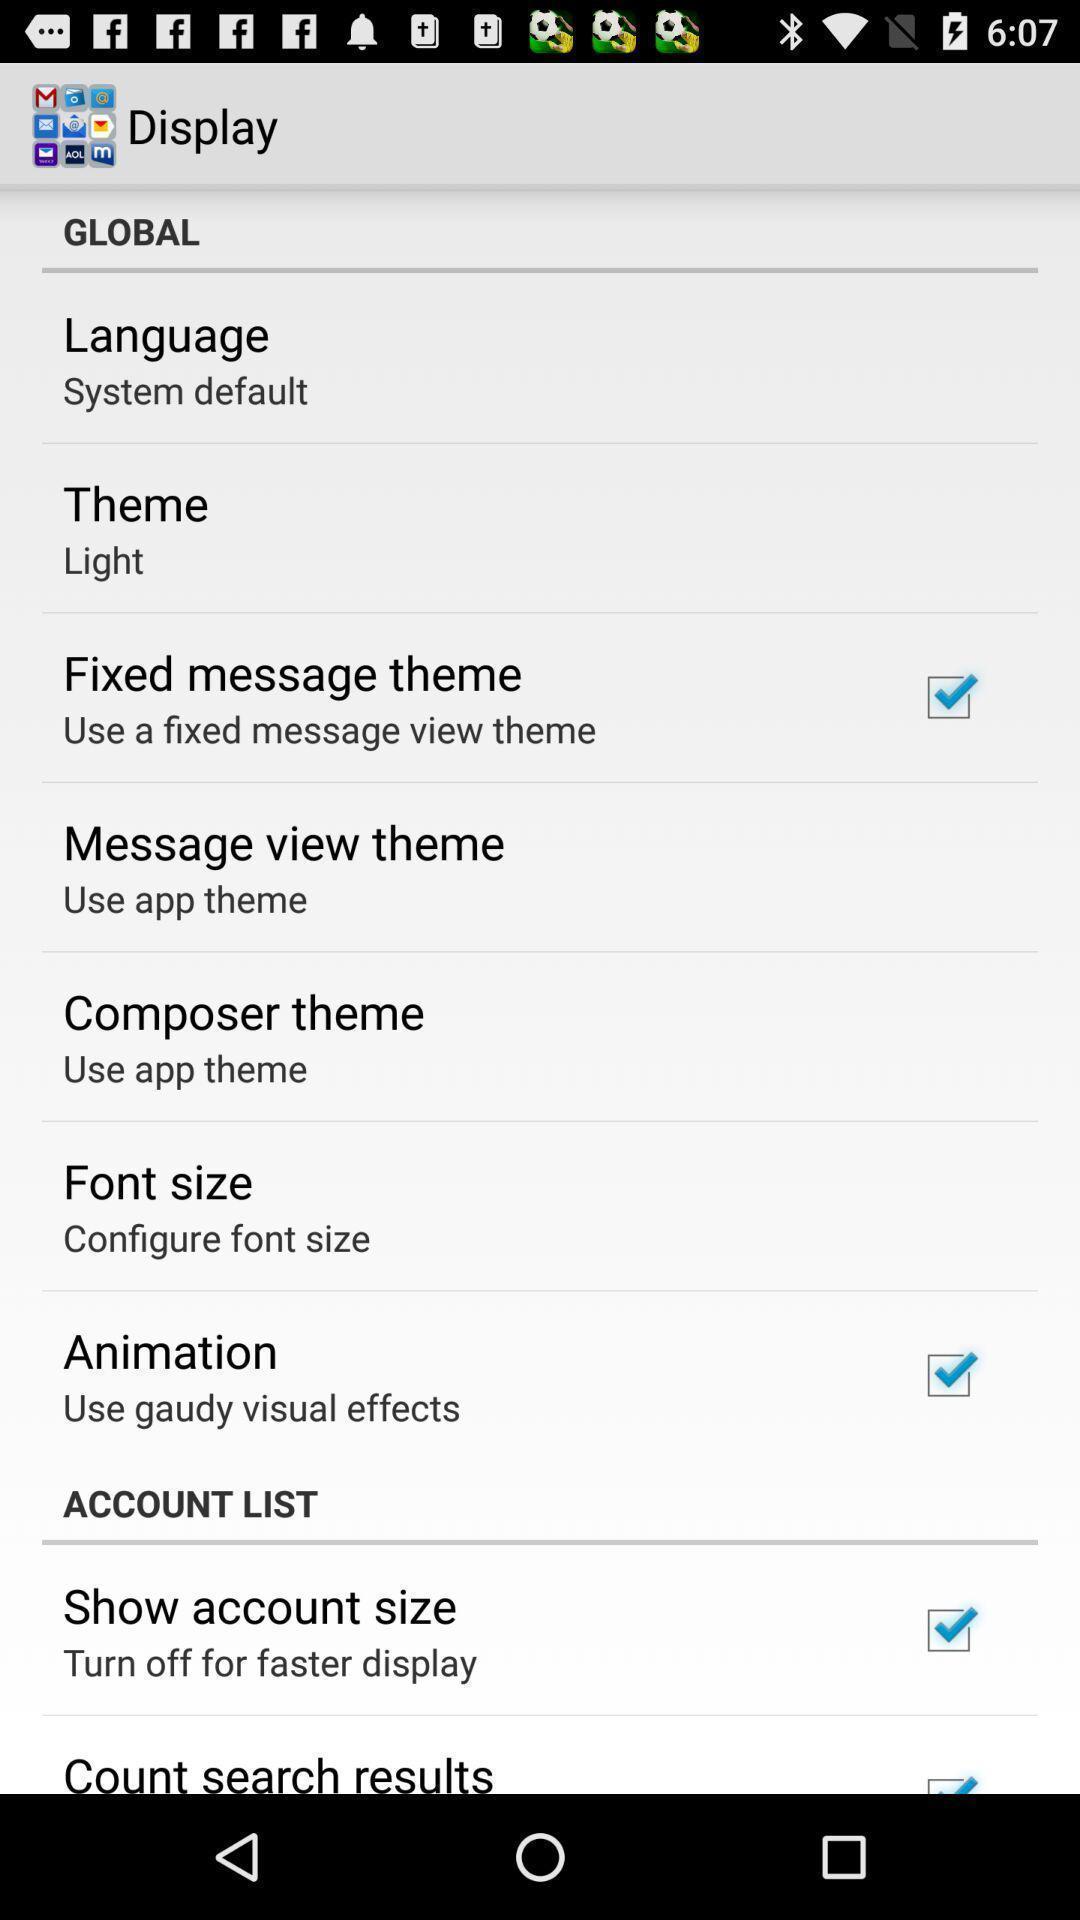Explain what's happening in this screen capture. Window displaying a display page. 